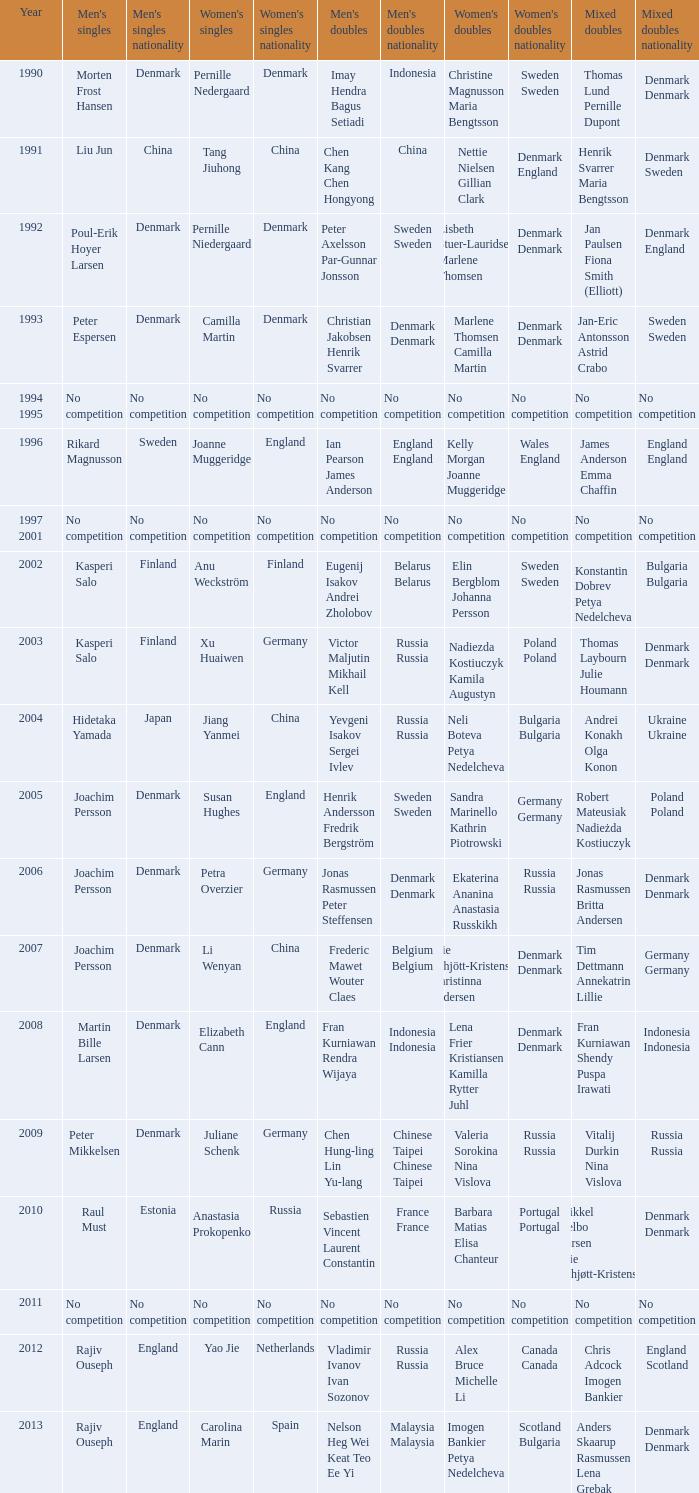What year did Carolina Marin win the Women's singles? 2013.0. 